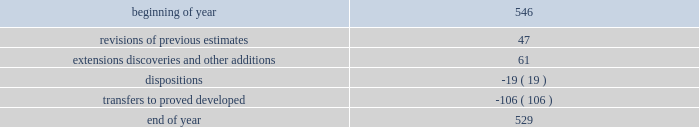Supplementary information on oil and gas producing activities ( unaudited ) 2018 proved reserves decreased by 168 mmboe primarily due to the following : 2022 revisions of previous estimates : increased by 84 mmboe including an increase of 108 mmboe associated with the acceleration of higher economic wells in the u.s .
Resource plays into the 5-year plan and an increase of 15 mmboe associated with wells to sales that were additions to the plan , partially offset by a decrease of 39 mmboe due to technical revisions across the business .
2022 extensions , discoveries , and other additions : increased by 102 mmboe primarily in the u.s .
Resource plays due to an increase of 69 mmboe associated with the expansion of proved areas and an increase of 33 mmboe associated with wells to sales from unproved categories .
2022 production : decreased by 153 mmboe .
2022 sales of reserves in place : decreased by 201 mmboe including 196 mmboe associated with the sale of our subsidiary in libya , 4 mmboe associated with divestitures of certain conventional assets in new mexico and michigan , and 1 mmboe associated with the sale of the sarsang block in kurdistan .
2017 proved reserves decreased by 647 mmboe primarily due to the following : 2022 revisions of previous estimates : increased by 49 mmboe primarily due to the acceleration of higher economic wells in the bakken into the 5-year plan resulting in an increase of 44 mmboe , with the remainder being due to revisions across the business .
2022 extensions , discoveries , and other additions : increased by 116 mmboe primarily due to an increase of 97 mmboe associated with the expansion of proved areas and wells to sales from unproved categories in oklahoma .
2022 purchases of reserves in place : increased by 28 mmboe from acquisitions of assets in the northern delaware basin in new mexico .
2022 production : decreased by 145 mmboe .
2022 sales of reserves in place : decreased by 695 mmboe including 685 mmboe associated with the sale of our canadian business and 10 mmboe associated with divestitures of certain conventional assets in oklahoma and colorado .
See item 8 .
Financial statements and supplementary data - note 5 to the consolidated financial statements for information regarding these dispositions .
2016 proved reserves decreased by 67 mmboe primarily due to the following : 2022 revisions of previous estimates : increased by 63 mmboe primarily due to an increase of 151 mmboe associated with the acceleration of higher economic wells in the u.s .
Resource plays into the 5-year plan and a decrease of 64 mmboe due to u.s .
Technical revisions .
2022 extensions , discoveries , and other additions : increased by 60 mmboe primarily associated with the expansion of proved areas and new wells to sales from unproven categories in oklahoma .
2022 purchases of reserves in place : increased by 34 mmboe from acquisition of stack assets in oklahoma .
2022 production : decreased by 144 mmboe .
2022 sales of reserves in place : decreased by 84 mmboe associated with the divestitures of certain wyoming and gulf of mexico assets .
Changes in proved undeveloped reserves as of december 31 , 2018 , 529 mmboe of proved undeveloped reserves were reported , a decrease of 17 mmboe from december 31 , 2017 .
The table shows changes in proved undeveloped reserves for 2018 : ( mmboe ) .

What percent of increases in extensions , discoveries , and other additions was associated with the expansion of proved areas and wells to sales from unproved categories in oklahoma? 
Computations: (97 / 116)
Answer: 0.83621. 